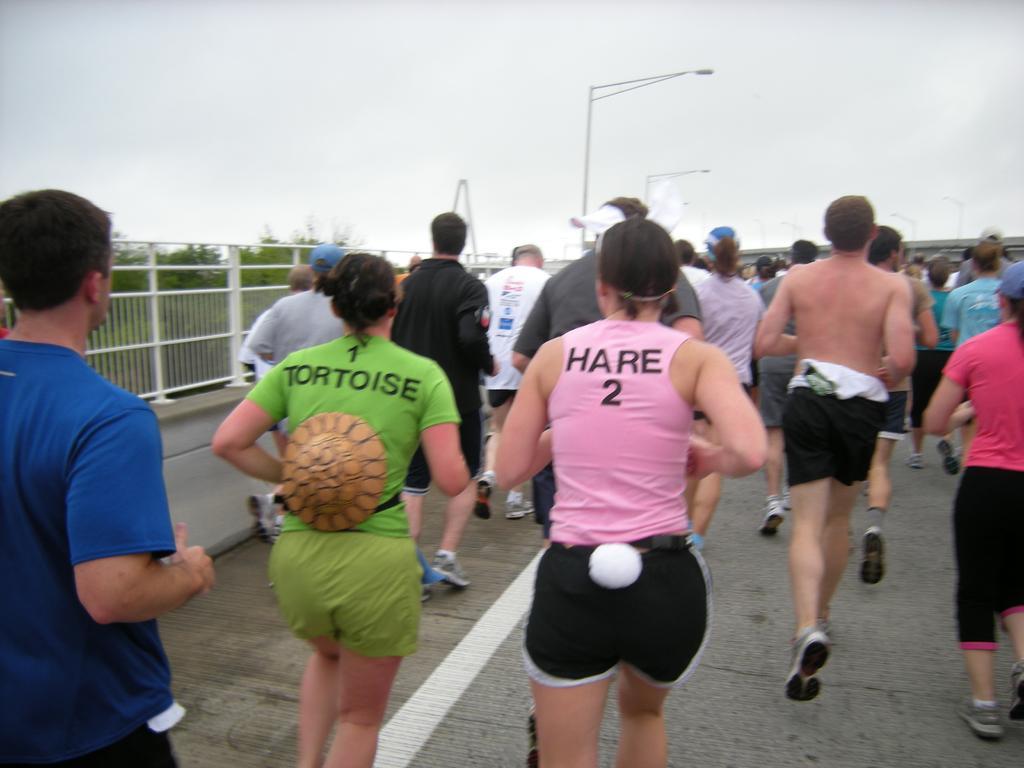Can you describe this image briefly? In this image we can see a few people running on the road, there is a fencing, trees, also we can see light poles, and the sky. 